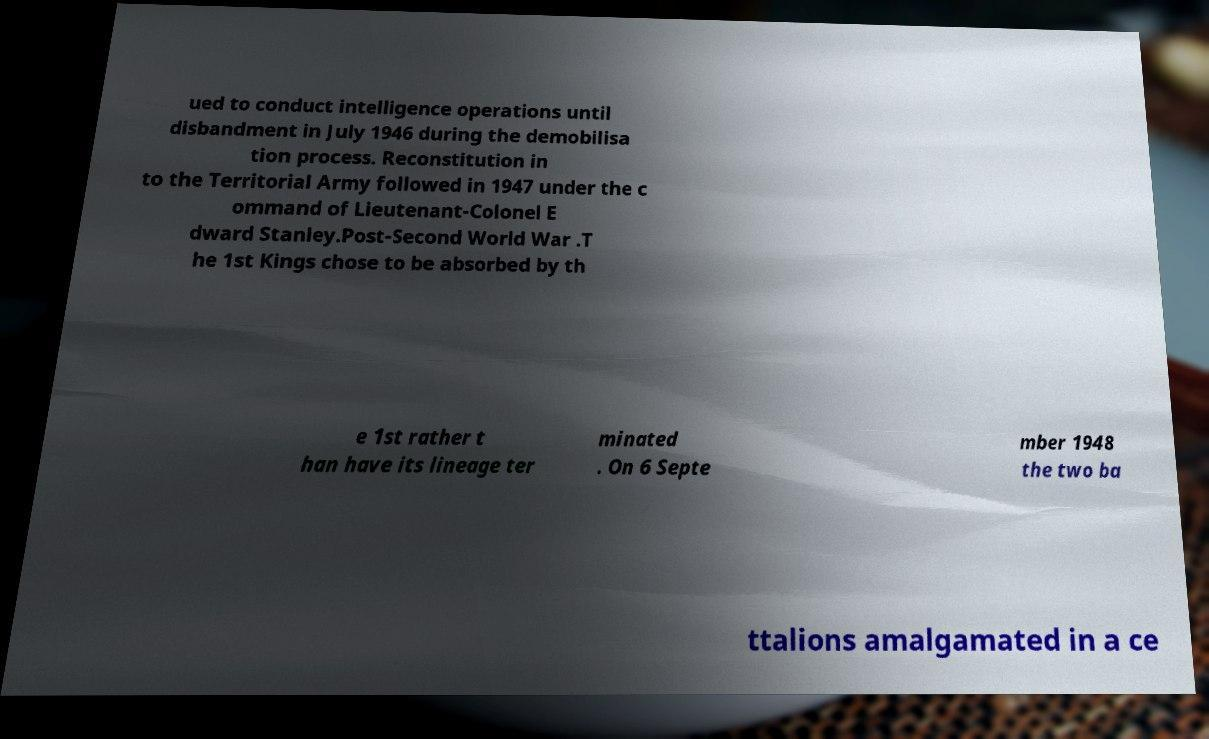Could you extract and type out the text from this image? ued to conduct intelligence operations until disbandment in July 1946 during the demobilisa tion process. Reconstitution in to the Territorial Army followed in 1947 under the c ommand of Lieutenant-Colonel E dward Stanley.Post-Second World War .T he 1st Kings chose to be absorbed by th e 1st rather t han have its lineage ter minated . On 6 Septe mber 1948 the two ba ttalions amalgamated in a ce 